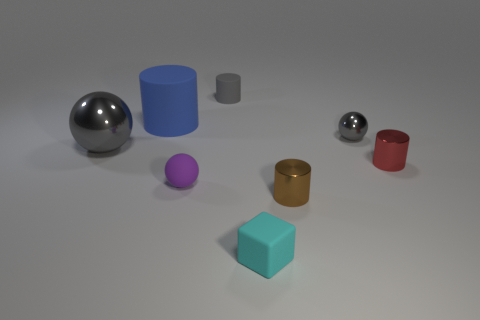What is the shape of the small metallic thing that is behind the tiny red thing?
Your response must be concise. Sphere. There is a gray ball to the right of the small ball that is on the left side of the small cyan thing; what is it made of?
Your answer should be very brief. Metal. Is there a metallic thing that has the same color as the big metal ball?
Ensure brevity in your answer.  Yes. There is a red object; is it the same size as the ball to the right of the gray cylinder?
Provide a succinct answer. Yes. How many cylinders are on the left side of the tiny matte object that is in front of the shiny thing that is in front of the red metal thing?
Your answer should be compact. 2. What number of shiny objects are behind the tiny purple object?
Your answer should be very brief. 3. What color is the shiny ball on the right side of the cylinder left of the tiny purple ball?
Your response must be concise. Gray. Are there an equal number of large gray metallic things that are in front of the red cylinder and small purple objects?
Your response must be concise. No. What is the material of the tiny thing that is behind the matte cylinder that is left of the sphere that is in front of the red shiny cylinder?
Make the answer very short. Rubber. What is the color of the shiny sphere to the right of the cyan thing?
Your answer should be compact. Gray. 